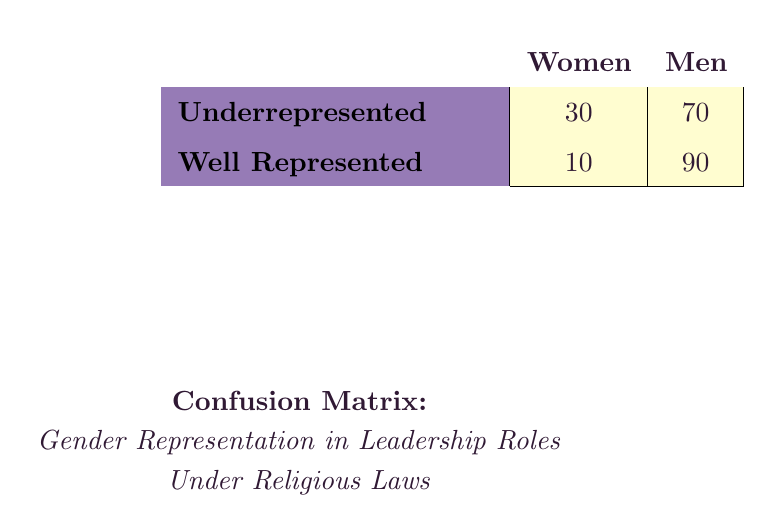What percentage of leadership roles are filled by women under Sharia law? According to the table, the proportion of women in leadership roles under Sharia law is listed as 10. To determine the percentage, we note that the total proportion of leaders (women + men) is 100. Therefore, the answer is 10%.
Answer: 10% What is the total number of well-represented women leaders across all religious laws? To find the total number of well-represented women leaders, we add the well-represented women leaders from each category: 10 (Sharia) + 15 (Hindu Personal Law) + 20 (Jewish Halakha) + 25 (Buddhist Law) + 30 (Christian Canon Law) = 100.
Answer: 100 Is the representation of women leaders in Hindu Personal Law greater than in Jewish Halakha? The proportion of women leaders in Hindu Personal Law is 15, while in Jewish Halakha, it is 20. Since 15 is not greater than 20, the answer is no.
Answer: No What is the average proportion of men in leadership roles across all religious laws? To calculate the average proportion of men, we first sum the proportions of men: 90 (Sharia) + 85 (Hindu Personal Law) + 80 (Jewish Halakha) + 75 (Buddhist Law) + 70 (Christian Canon Law) = 400. There are 5 categories, so the average is 400/5 = 80.
Answer: 80 Which religious law has the least proportion of women in leadership roles? By examining the table, we see that the lowest proportion of women is under Sharia law, which is 10, compared to the other laws. Therefore, the conclusion is that Sharia has the least proportion of women in leadership roles.
Answer: Sharia What is the difference in the number of underrepresented men leaders and well-represented men leaders? The confusion matrix shows that there are 70 underrepresented men leaders and 90 well-represented men leaders. The difference is calculated by subtracting the number of underrepresented men leaders from well-represented men leaders: 90 - 70 = 20.
Answer: 20 Are there more underrepresented women leaders than well-represented women leaders? Based on the table, there are 30 underrepresented women leaders and 10 well-represented women leaders. Since 30 is greater than 10, the answer is yes.
Answer: Yes What is the total representation of both women leaders across all categories? To find the total representation of both women leaders, we add the proportions of women leaders from all the categories: 10 (Sharia) + 15 (Hindu Personal Law) + 20 (Jewish Halakha) + 25 (Buddhist Law) + 30 (Christian Canon Law) = 100.
Answer: 100 